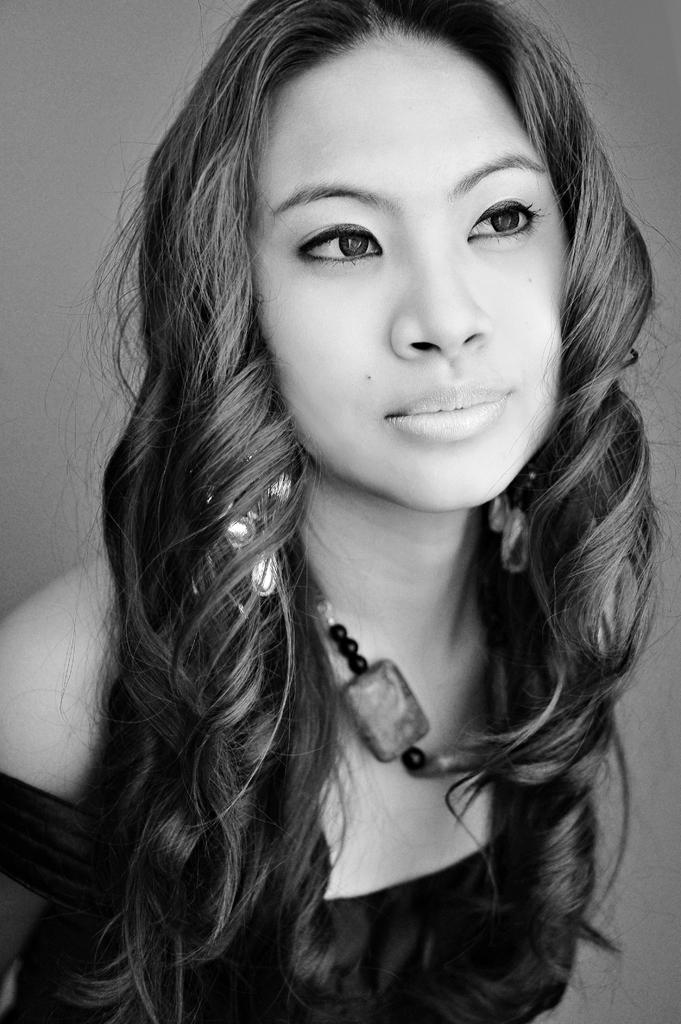What is the color scheme of the image? The image is black and white. Who is present in the image? There is a woman in the image. What is the woman wearing? The woman is wearing a dress, earrings, and a chain. What type of leather is the scarecrow wearing in the image? There is no scarecrow present in the image, and therefore no leather can be observed. 